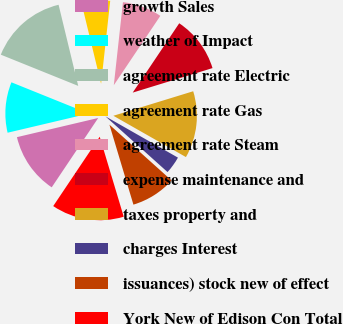Convert chart to OTSL. <chart><loc_0><loc_0><loc_500><loc_500><pie_chart><fcel>growth Sales<fcel>weather of Impact<fcel>agreement rate Electric<fcel>agreement rate Gas<fcel>agreement rate Steam<fcel>expense maintenance and<fcel>taxes property and<fcel>charges Interest<fcel>issuances) stock new of effect<fcel>York New of Edison Con Total<nl><fcel>11.91%<fcel>9.79%<fcel>15.11%<fcel>5.53%<fcel>7.66%<fcel>10.85%<fcel>12.98%<fcel>3.4%<fcel>8.72%<fcel>14.04%<nl></chart> 